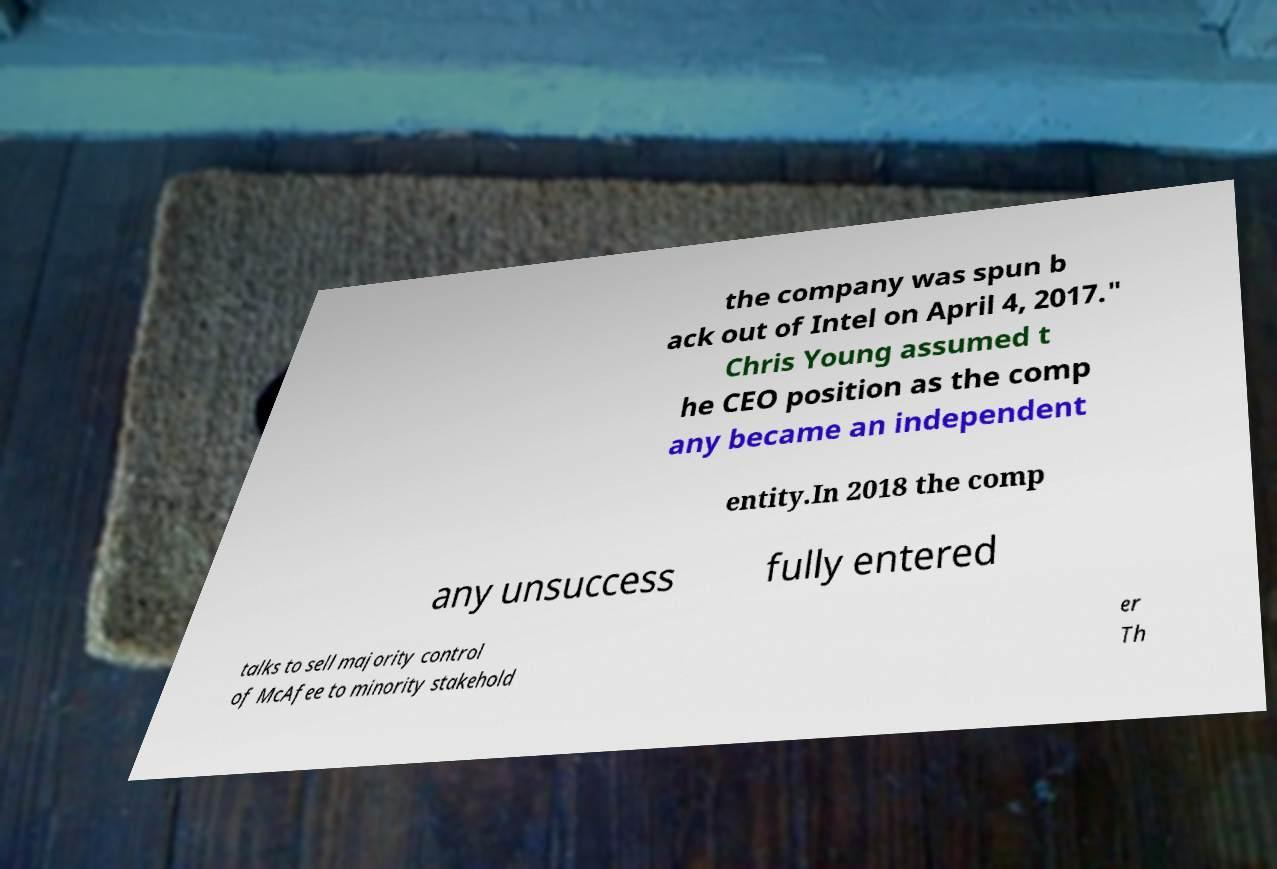Could you assist in decoding the text presented in this image and type it out clearly? the company was spun b ack out of Intel on April 4, 2017." Chris Young assumed t he CEO position as the comp any became an independent entity.In 2018 the comp any unsuccess fully entered talks to sell majority control of McAfee to minority stakehold er Th 